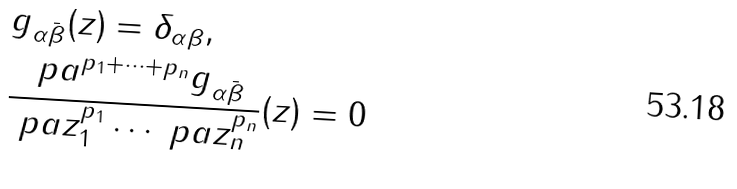<formula> <loc_0><loc_0><loc_500><loc_500>& g _ { \alpha \bar { \beta } } ( z ) = \delta _ { \alpha \beta } , \\ & \frac { \ p a ^ { p _ { 1 } + \cdots + p _ { n } } g _ { \alpha \bar { \beta } } } { \ p a z _ { 1 } ^ { p _ { 1 } } \cdots \ p a z _ { n } ^ { p _ { n } } } ( z ) = 0</formula> 